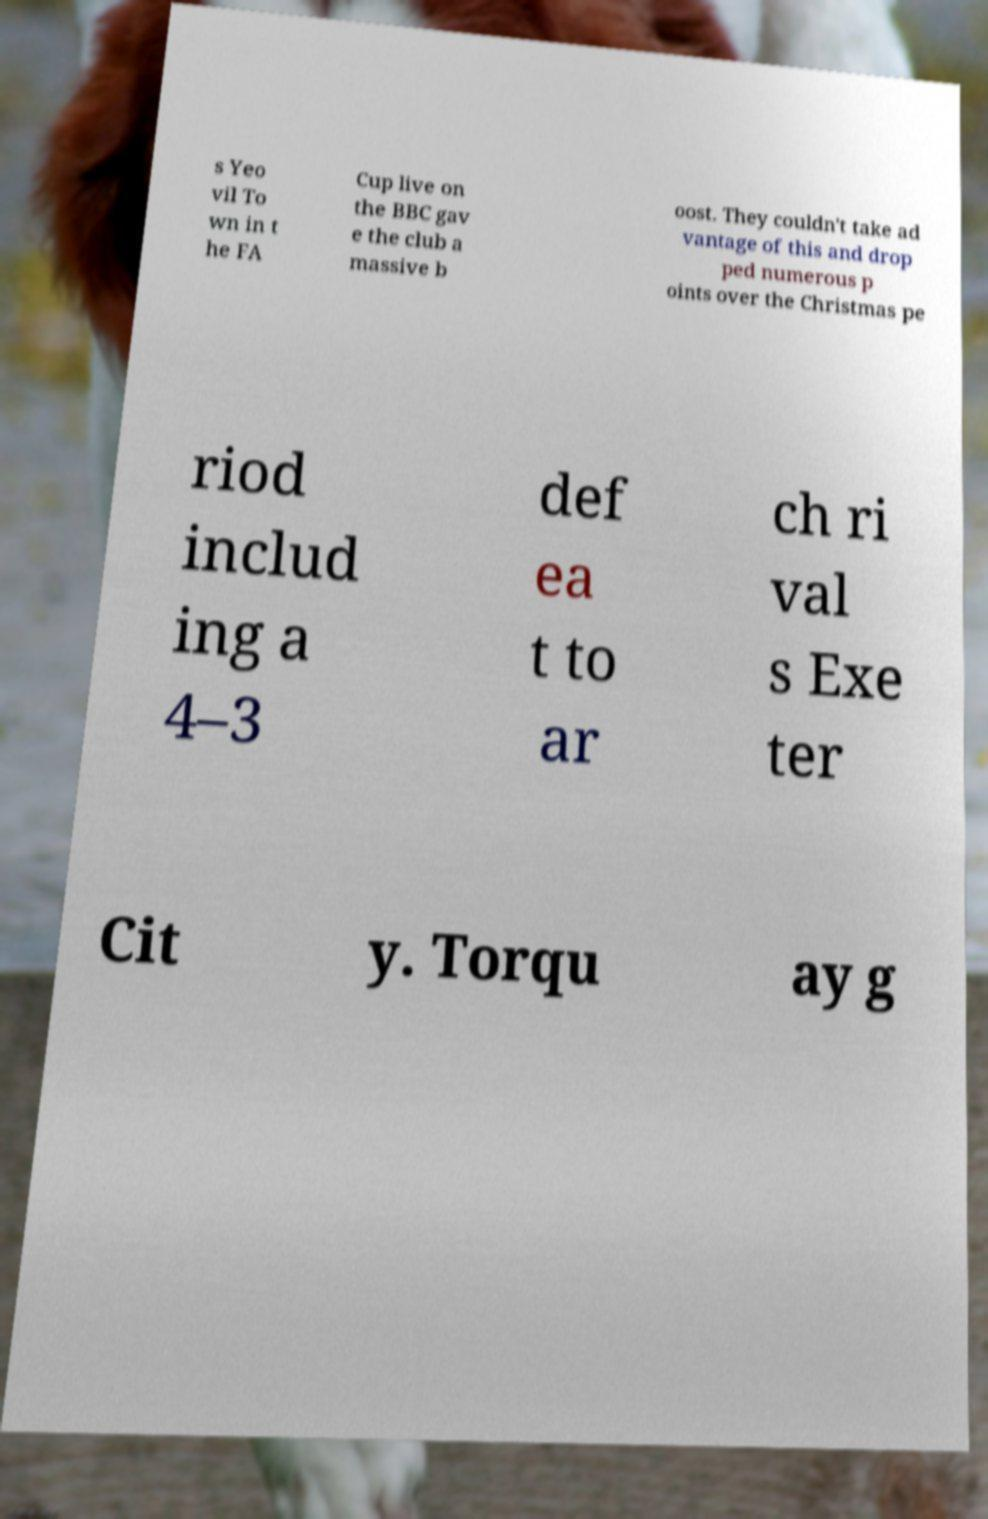Can you read and provide the text displayed in the image?This photo seems to have some interesting text. Can you extract and type it out for me? s Yeo vil To wn in t he FA Cup live on the BBC gav e the club a massive b oost. They couldn't take ad vantage of this and drop ped numerous p oints over the Christmas pe riod includ ing a 4–3 def ea t to ar ch ri val s Exe ter Cit y. Torqu ay g 